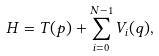Convert formula to latex. <formula><loc_0><loc_0><loc_500><loc_500>H = T ( p ) + \sum ^ { N - 1 } _ { i = 0 } V _ { i } ( q ) ,</formula> 